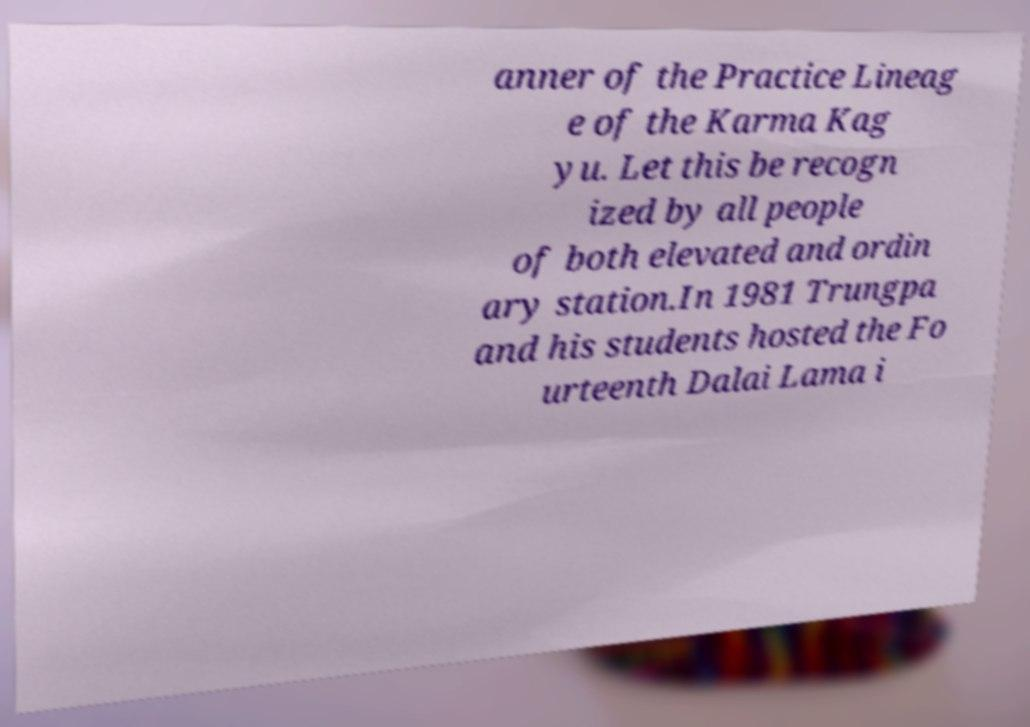Can you accurately transcribe the text from the provided image for me? anner of the Practice Lineag e of the Karma Kag yu. Let this be recogn ized by all people of both elevated and ordin ary station.In 1981 Trungpa and his students hosted the Fo urteenth Dalai Lama i 